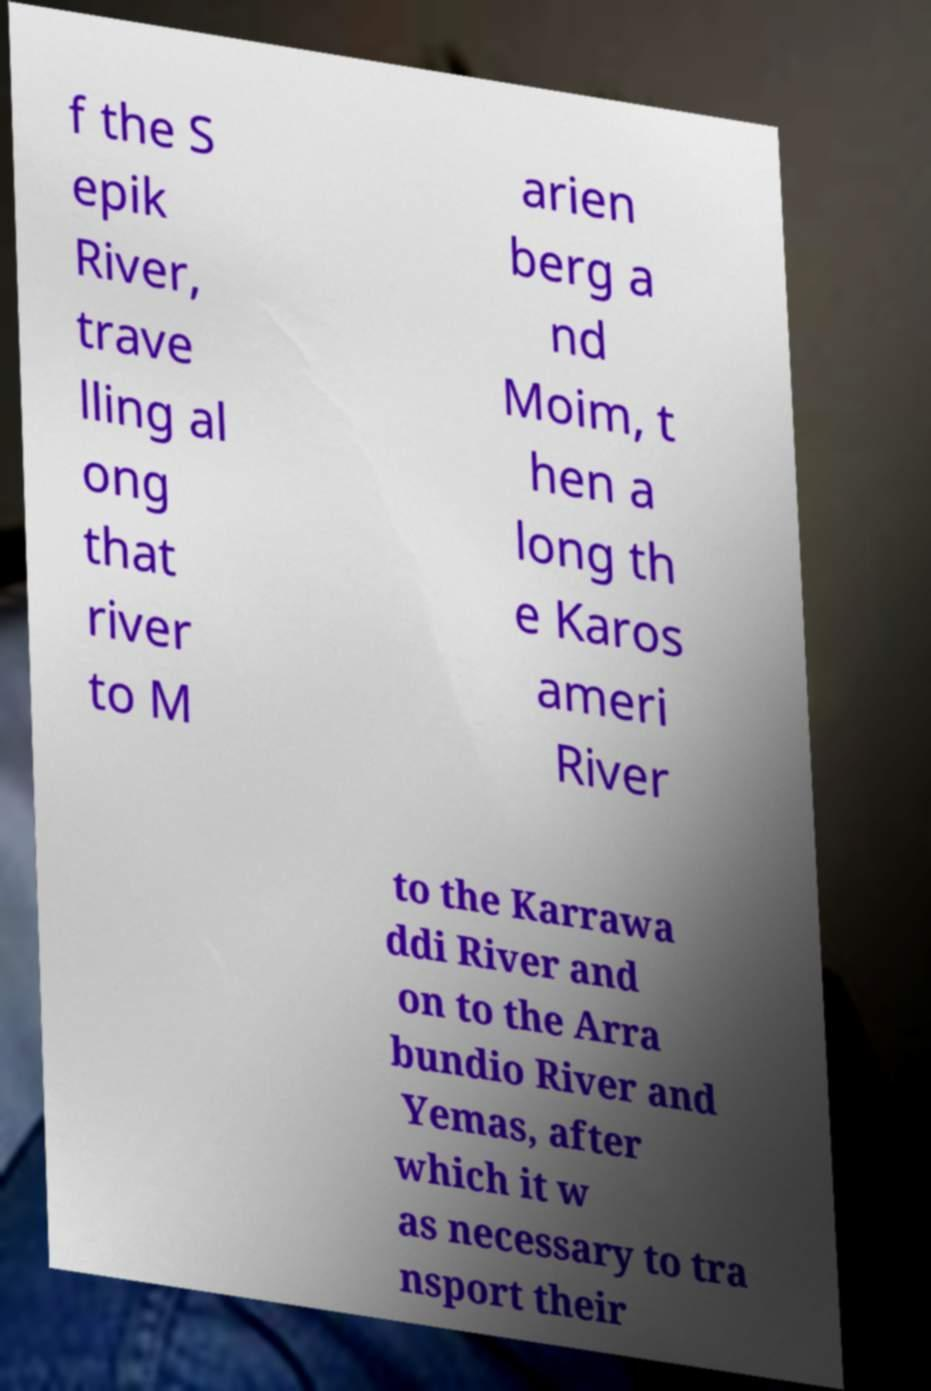Can you accurately transcribe the text from the provided image for me? f the S epik River, trave lling al ong that river to M arien berg a nd Moim, t hen a long th e Karos ameri River to the Karrawa ddi River and on to the Arra bundio River and Yemas, after which it w as necessary to tra nsport their 